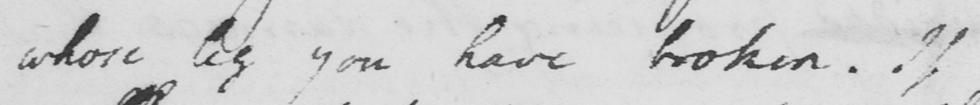What does this handwritten line say? whose leg you have broken. If 